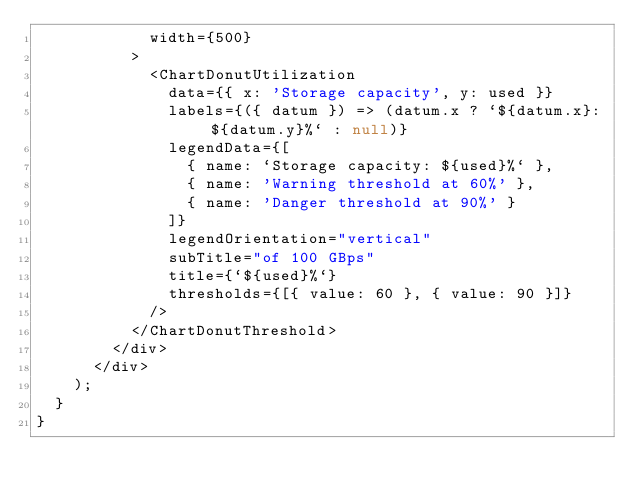<code> <loc_0><loc_0><loc_500><loc_500><_TypeScript_>            width={500}
          >
            <ChartDonutUtilization
              data={{ x: 'Storage capacity', y: used }}
              labels={({ datum }) => (datum.x ? `${datum.x}: ${datum.y}%` : null)}
              legendData={[
                { name: `Storage capacity: ${used}%` },
                { name: 'Warning threshold at 60%' },
                { name: 'Danger threshold at 90%' }
              ]}
              legendOrientation="vertical"
              subTitle="of 100 GBps"
              title={`${used}%`}
              thresholds={[{ value: 60 }, { value: 90 }]}
            />
          </ChartDonutThreshold>
        </div>
      </div>
    );
  }
}
</code> 